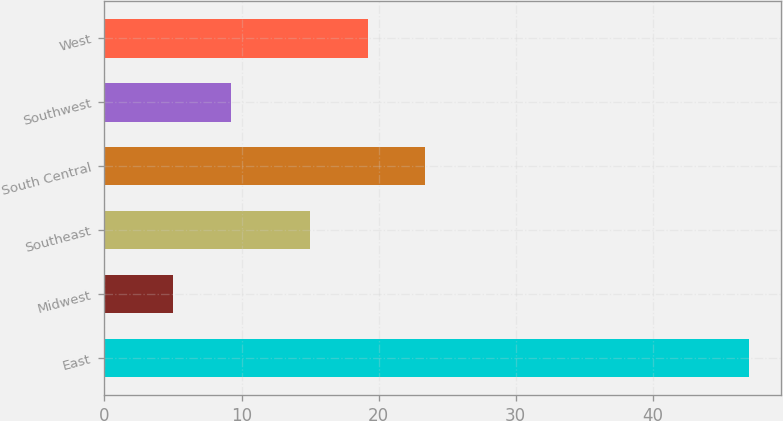Convert chart to OTSL. <chart><loc_0><loc_0><loc_500><loc_500><bar_chart><fcel>East<fcel>Midwest<fcel>Southeast<fcel>South Central<fcel>Southwest<fcel>West<nl><fcel>47<fcel>5<fcel>15<fcel>23.4<fcel>9.2<fcel>19.2<nl></chart> 